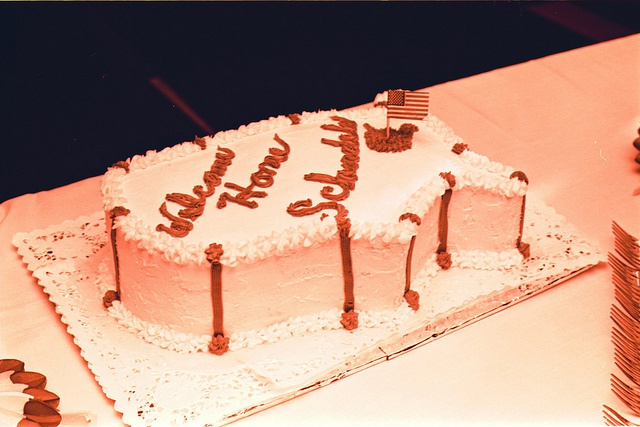Describe the objects in this image and their specific colors. I can see dining table in olive, ivory, tan, and salmon tones, cake in olive, tan, ivory, and salmon tones, fork in olive, red, salmon, and brown tones, fork in olive, red, brown, and salmon tones, and fork in olive, red, brown, salmon, and maroon tones in this image. 